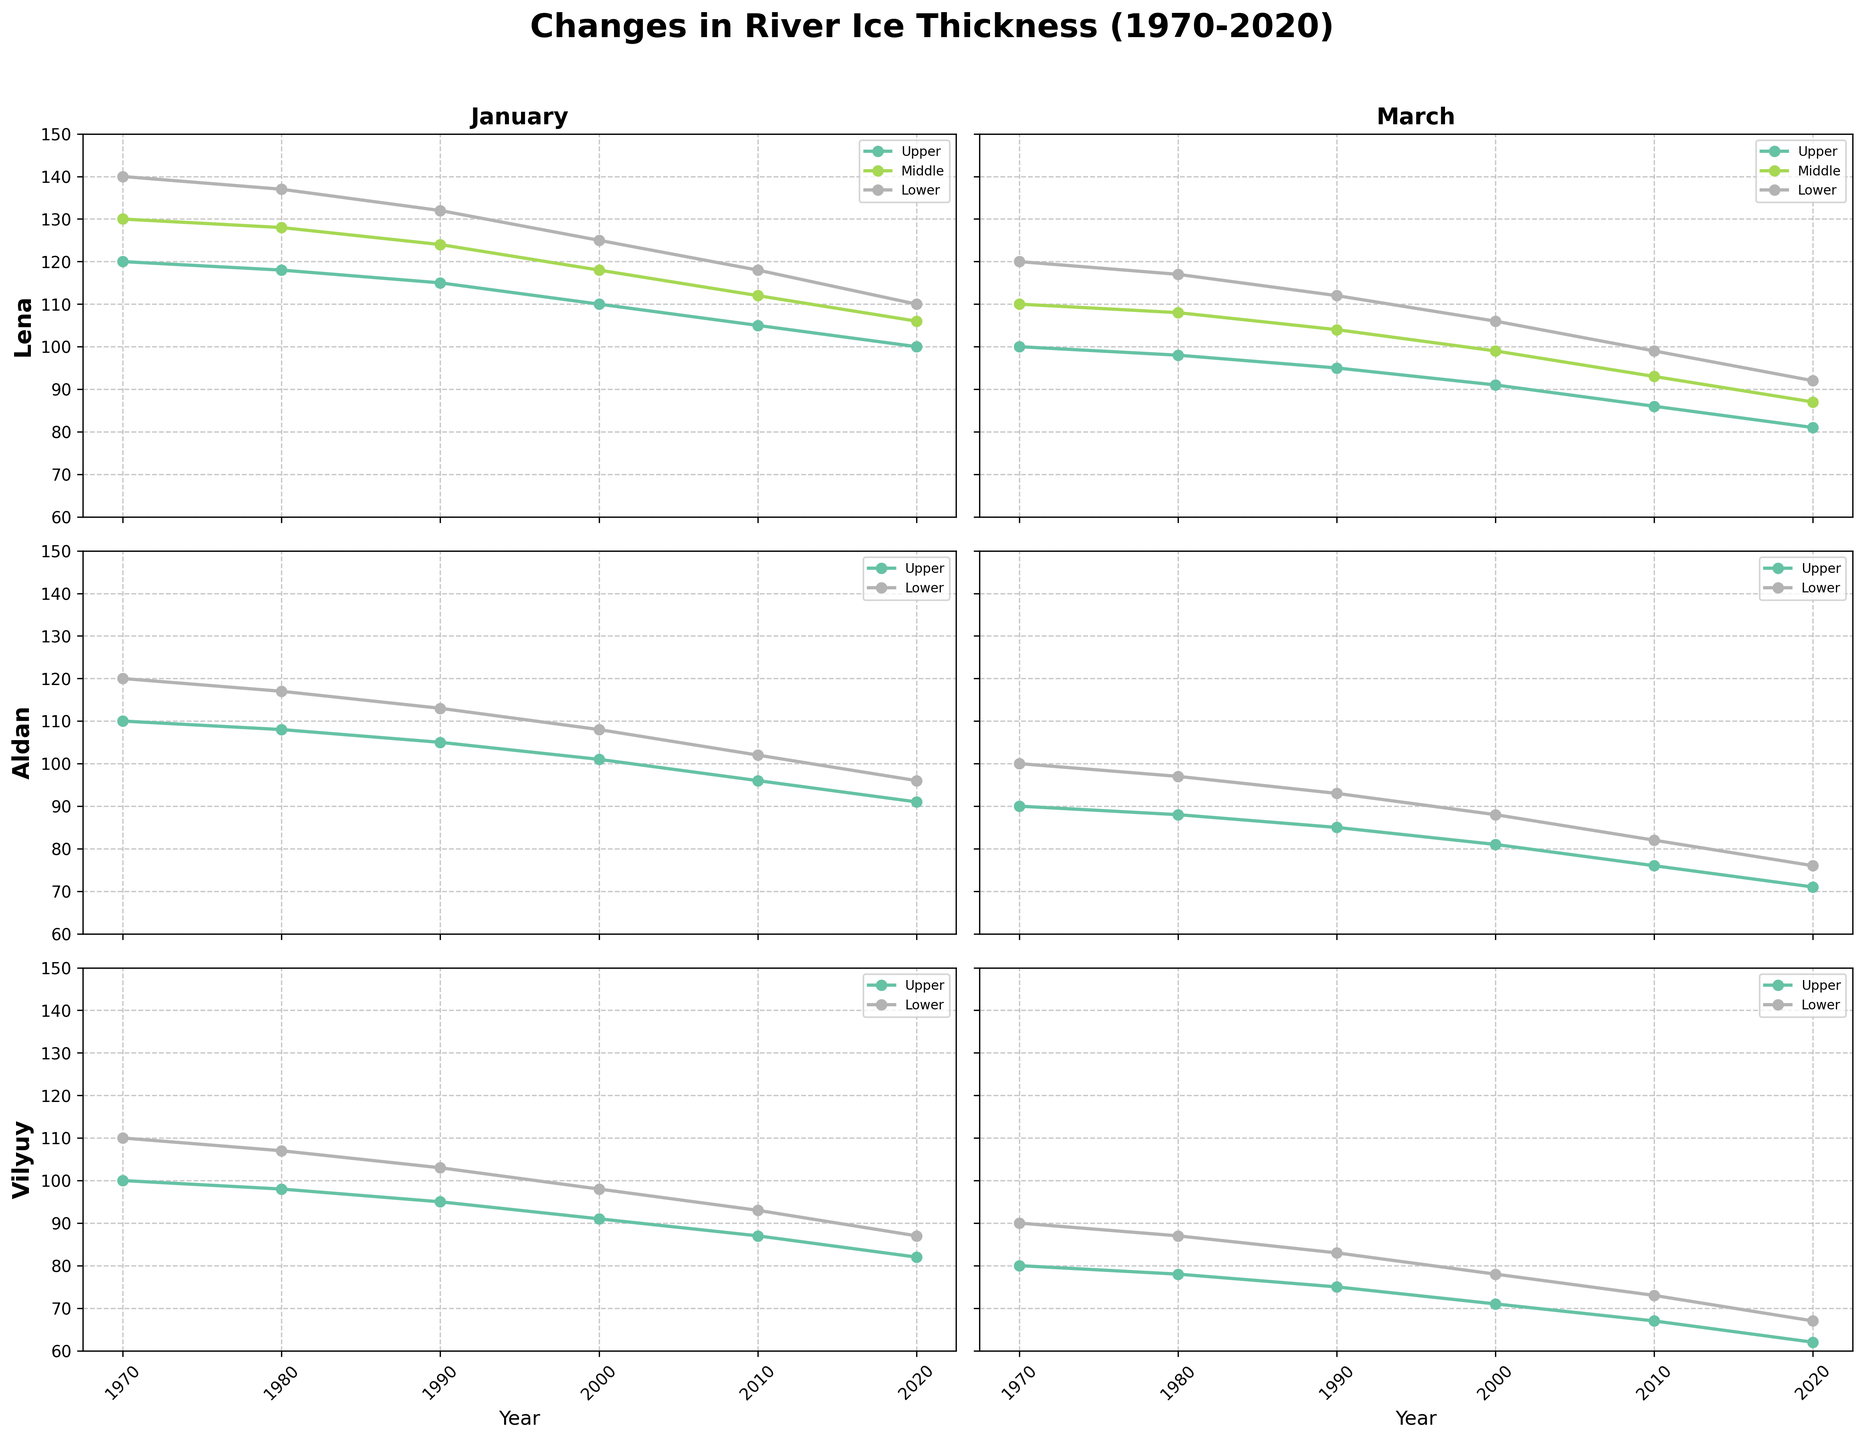How has the river ice thickness in the Lower section of the Lena River changed in January over the past 50 years? The plot for the Lower section of the Lena River in January shows decreasing ice thickness values from 140 cm in 1970 to 110 cm in 2020.
Answer: Decreased from 140 cm to 110 cm Which river experiences the greatest reduction in ice thickness in January, and by how much? By comparing the distance between the 1970 and 2020 points for each river section in January, the Vilyuy River Upper section shows the largest reduction, from 100 cm to 82 cm, a reduction of 18 cm.
Answer: Vilyuy Upper, 18 cm In March, what is the general trend observed in the ice thickness of the Aldan River Upper section? The plot for the Aldan River Upper section in March shows a consistent downward trend from 90 cm in 1970 to 71 cm in 2020.
Answer: Downward trend Comparing the ice thickness in January between the Upper and Lower sections of the Aldan River, which section shows more ice thickness in 2020? In 2020, the Lower section of the Aldan River shows an ice thickness of 96 cm, whereas the Upper section shows 91 cm. Therefore, the Lower section has more ice thickness.
Answer: Lower section What can be inferred about the change in ice thickness for the Upper section of the Lena River in January versus March? The January chart shows a decrease in ice thickness from 120 cm in 1970 to 100 cm in 2020, while the March chart shows a decrease from 100 cm to 81 cm over the same period. Both show a decrease, but the decline is relatively more in March compared to January.
Answer: Greater relative decrease in March Which month, January or March, generally shows a thicker ice profile across all rivers in 1970? By comparing the January and March plots for the year 1970, January shows generally higher ice thickness values compared to March across all rivers and sections.
Answer: January What is the percentage decrease in ice thickness for the Middle section of Lena River in January from 1970 to 2020? The ice thickness decreased from 130 cm in 1970 to 106 cm in 2020. The percentage decrease is calculated as ((130-106)/130) * 100 = 18.46%.
Answer: 18.46% Was there any river section that maintained its ice thickness from 1970 to 1980 in either January or March? By examining the plots, no river section maintained the same ice thickness; all sections experienced a reduction or increase from 1970 to 1980.
Answer: No 